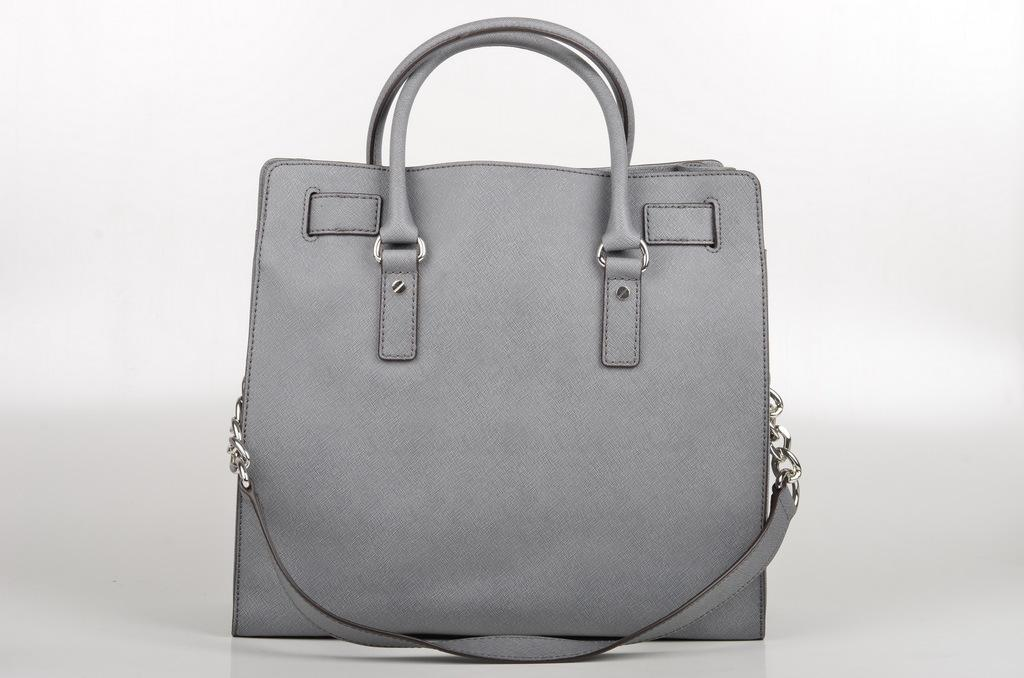What object is located in the center of the image? There is a handbag in the center of the image. What can be seen in the background of the image? The background of the image is white. What nation is represented by the handbag in the image? The image does not depict a nation or any national symbols; it simply features a handbag. Can you see any veins in the handbag in the image? There are no veins visible in the handbag, as it is an inanimate object made of fabric or other materials. 